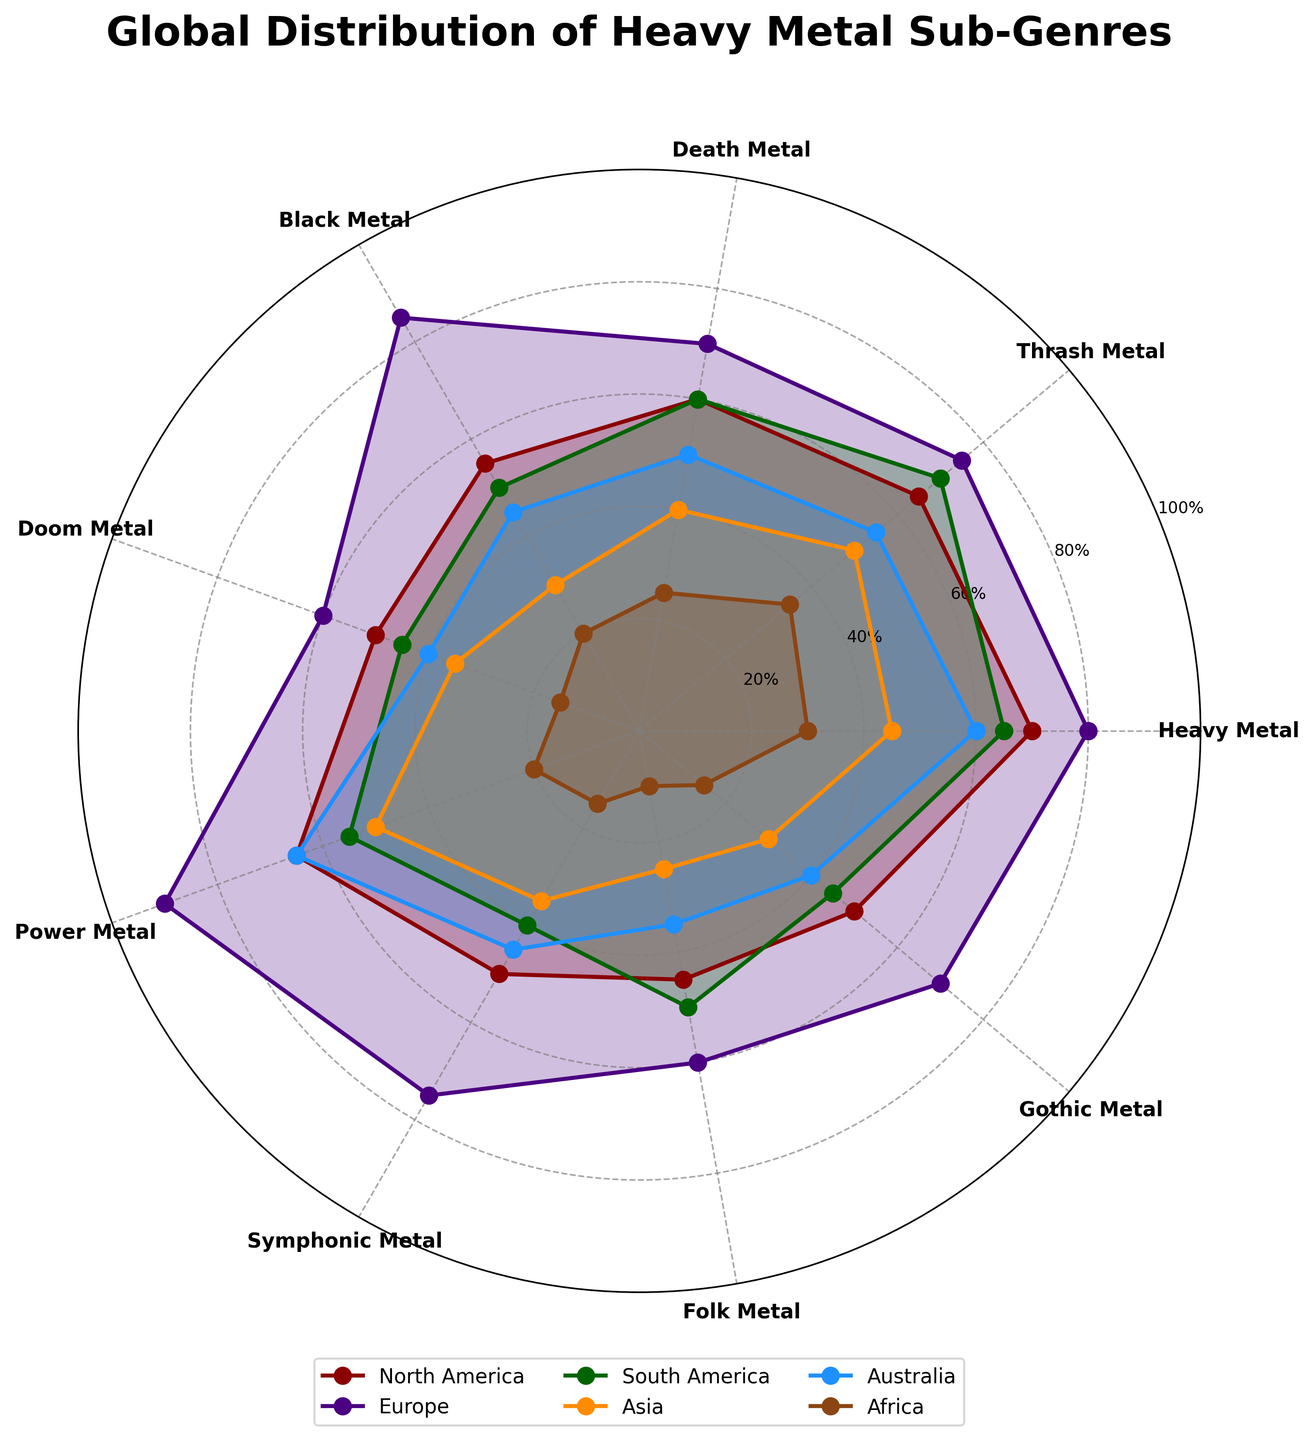What's the title of the radar chart? The title of the radar chart is positioned prominently at the top of the figure and can be read directly.
Answer: Global Distribution of Heavy Metal Sub-Genres Which region has the highest prevalence of Power Metal? By examining the point labeled "Power Metal" on the radar chart, you can see which region has the largest value corresponding to it. Europe has the highest value for Power Metal at 90.
Answer: Europe What is the range of values for Thrash Metal? To determine the range, look at the maximum and minimum values for Thrash Metal across all regions. The highest value is 75 (Europe) and the lowest value is 35 (Africa), so the range is 75-35 = 40.
Answer: 40 Which sub-genre has the largest variation in prevalence across regions? We examine each sub-genre and compare the spread between the highest and lowest values. Power Metal has the largest variation: the highest value is 90 (Europe) and the lowest is 20 (Africa), giving a variation of 70.
Answer: Power Metal How does North America's preference for Folk Metal compare with Australia's? To compare the values, look at the points labeled "Folk Metal" for North America and Australia. North America has a value of 45, while Australia has a value of 35. Therefore, North America has a higher preference for Folk Metal than Australia.
Answer: North America Which sub-genre has the lowest prevalence in Africa? Look at the values corresponding to Africa for each sub-genre. Folk Metal has the lowest value at 10.
Answer: Folk Metal Which two sub-genres have an equal prevalence in South America? Compare the values for each sub-genre in South America to find any equal values. Doom Metal and Gothic Metal both have a value of 45 in South America.
Answer: Doom Metal and Gothic Metal What is the average prevalence of Heavy Metal in all regions? Compute the average by summing the prevalence values of Heavy Metal in all regions and dividing by the number of regions. (70 + 80 + 65 + 45 + 60 + 30) / 6 = 350 / 6 ≈ 58.33.
Answer: 58.33 Which sub-genre shows the highest regional affinity in Asia? Review the values labeled for Asia across all sub-genres. Power Metal shows the highest regional affinity with a value of 50 in Asia.
Answer: Power Metal 